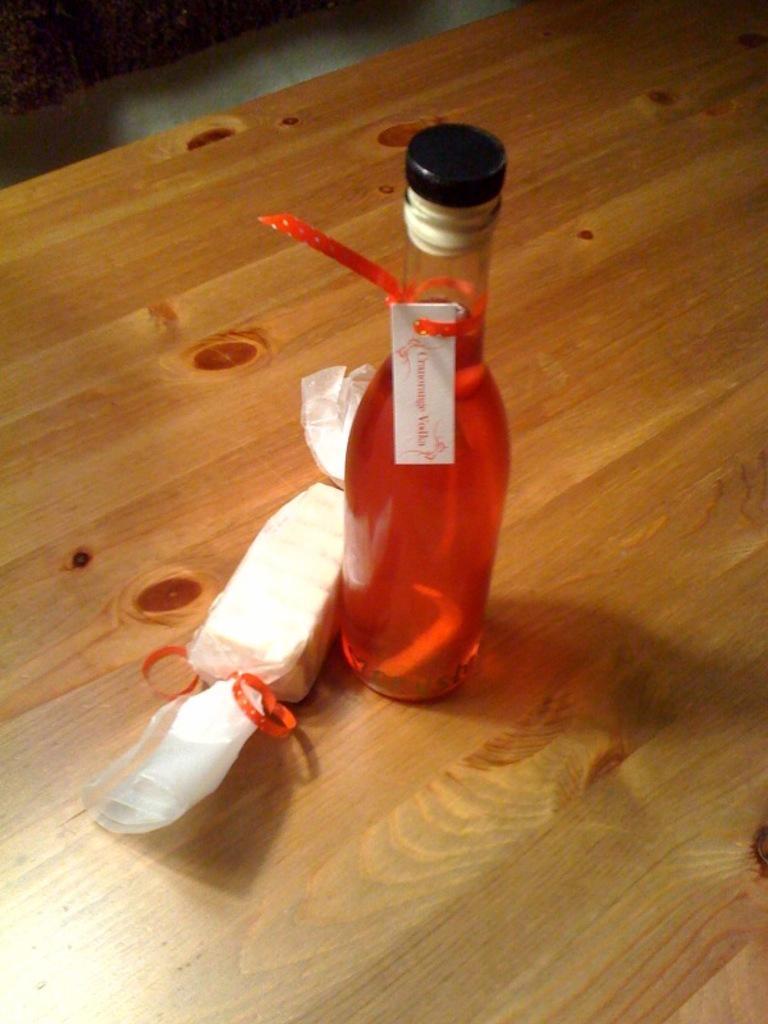Describe this image in one or two sentences. This is a picture, in this picture there is a bottle with liquid. The bottle is on a wooden table. On the left side of the bottle there is a chocolate with a wrapper. 